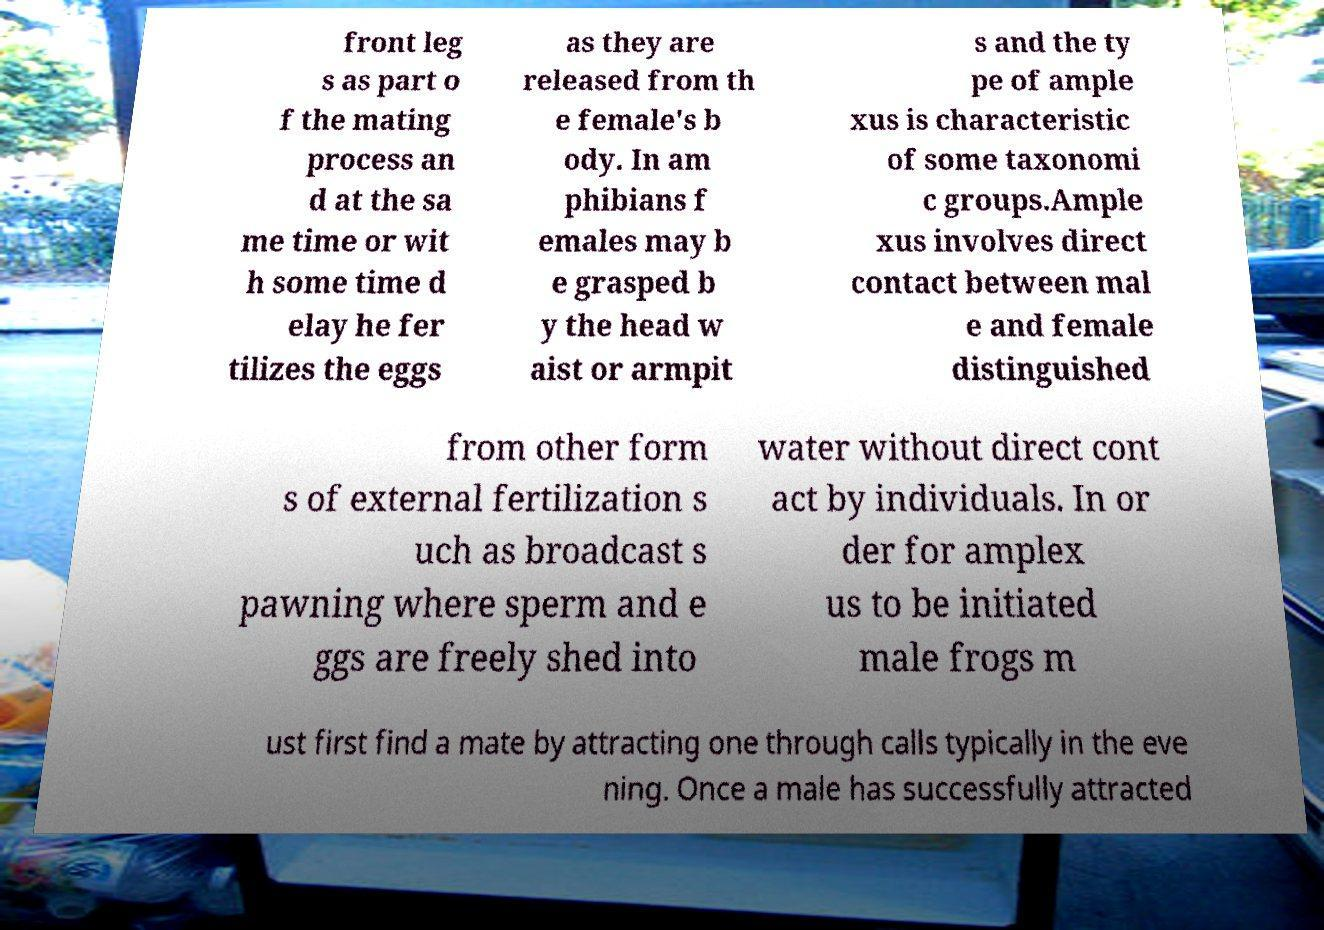Please identify and transcribe the text found in this image. front leg s as part o f the mating process an d at the sa me time or wit h some time d elay he fer tilizes the eggs as they are released from th e female's b ody. In am phibians f emales may b e grasped b y the head w aist or armpit s and the ty pe of ample xus is characteristic of some taxonomi c groups.Ample xus involves direct contact between mal e and female distinguished from other form s of external fertilization s uch as broadcast s pawning where sperm and e ggs are freely shed into water without direct cont act by individuals. In or der for amplex us to be initiated male frogs m ust first find a mate by attracting one through calls typically in the eve ning. Once a male has successfully attracted 